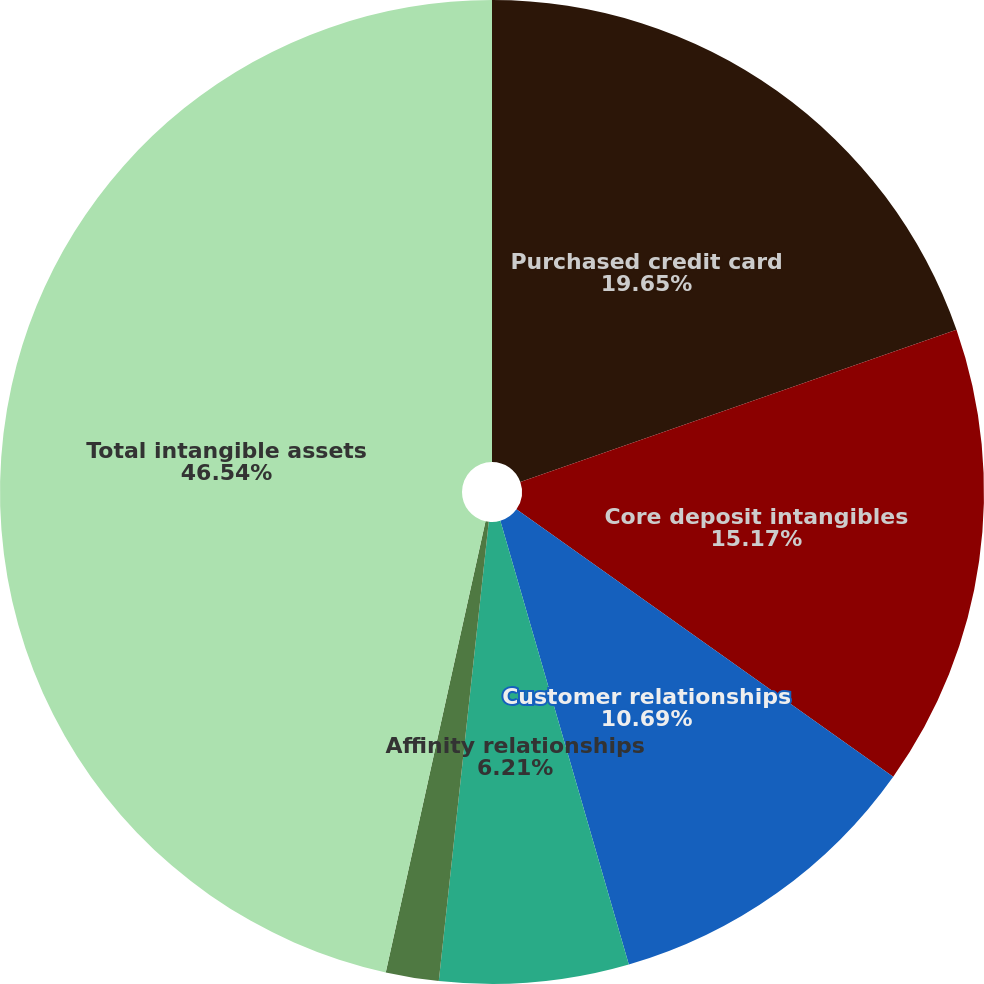<chart> <loc_0><loc_0><loc_500><loc_500><pie_chart><fcel>Purchased credit card<fcel>Core deposit intangibles<fcel>Customer relationships<fcel>Affinity relationships<fcel>Other intangibles<fcel>Total intangible assets<nl><fcel>19.65%<fcel>15.17%<fcel>10.69%<fcel>6.21%<fcel>1.74%<fcel>46.53%<nl></chart> 